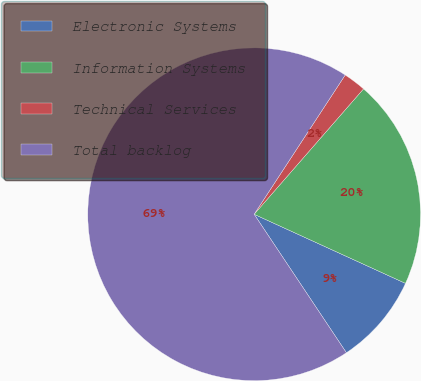<chart> <loc_0><loc_0><loc_500><loc_500><pie_chart><fcel>Electronic Systems<fcel>Information Systems<fcel>Technical Services<fcel>Total backlog<nl><fcel>8.83%<fcel>20.4%<fcel>2.2%<fcel>68.57%<nl></chart> 